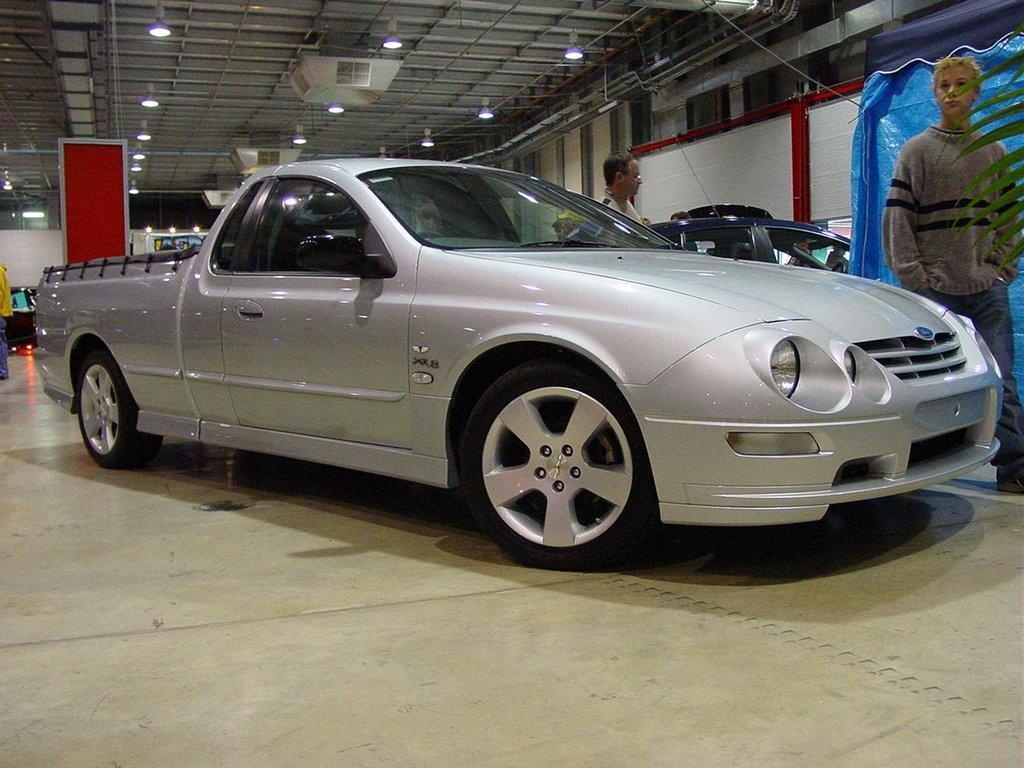How would you summarize this image in a sentence or two? This image consists of a car. It is in ash color. There are two persons standing in the middle. There are lights at the top. 